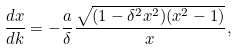Convert formula to latex. <formula><loc_0><loc_0><loc_500><loc_500>\frac { d x } { d k } = - \frac { a } { \delta } \frac { \sqrt { ( 1 - \delta ^ { 2 } x ^ { 2 } ) ( x ^ { 2 } - 1 ) } } { x } ,</formula> 